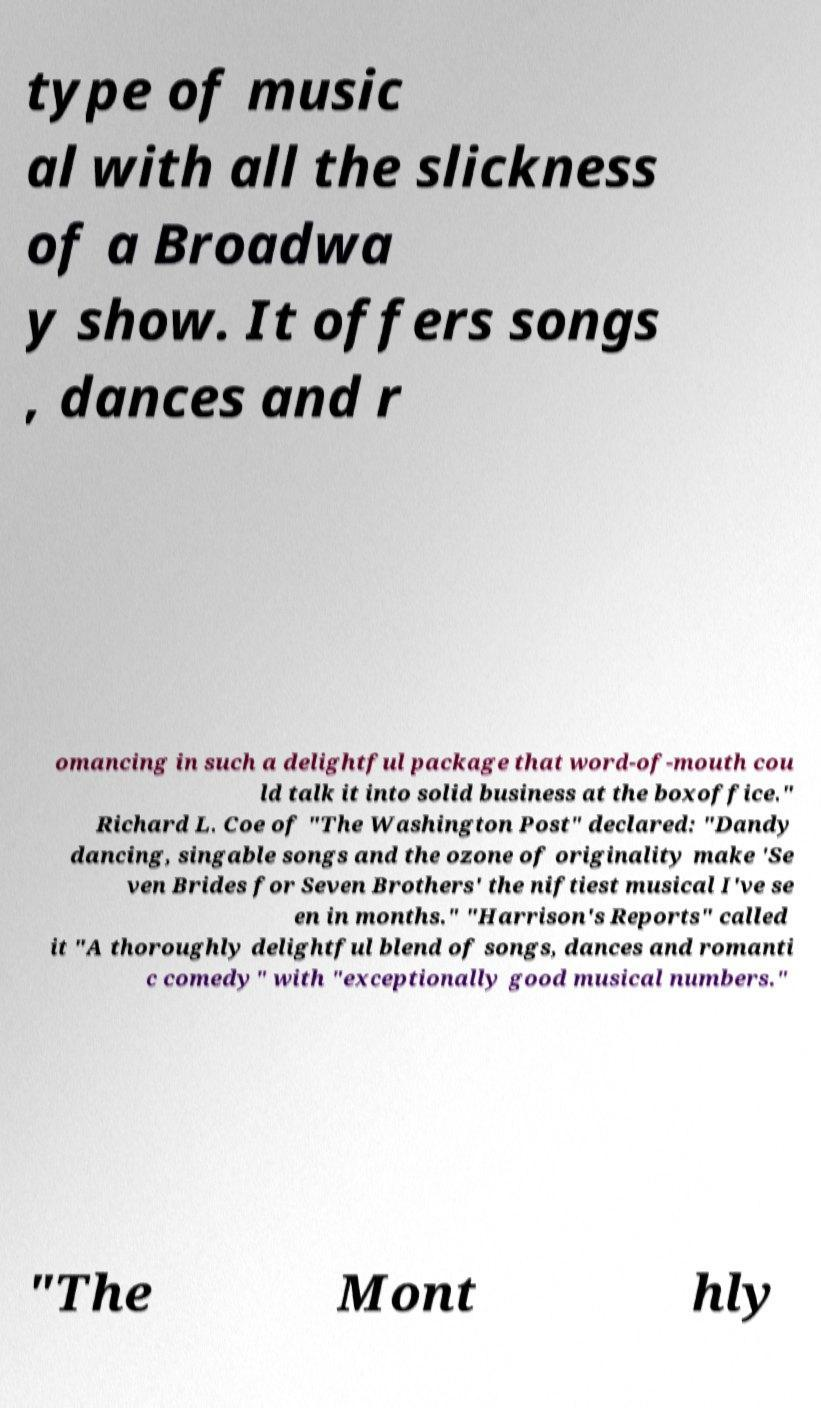There's text embedded in this image that I need extracted. Can you transcribe it verbatim? type of music al with all the slickness of a Broadwa y show. It offers songs , dances and r omancing in such a delightful package that word-of-mouth cou ld talk it into solid business at the boxoffice." Richard L. Coe of "The Washington Post" declared: "Dandy dancing, singable songs and the ozone of originality make 'Se ven Brides for Seven Brothers' the niftiest musical I've se en in months." "Harrison's Reports" called it "A thoroughly delightful blend of songs, dances and romanti c comedy" with "exceptionally good musical numbers." "The Mont hly 